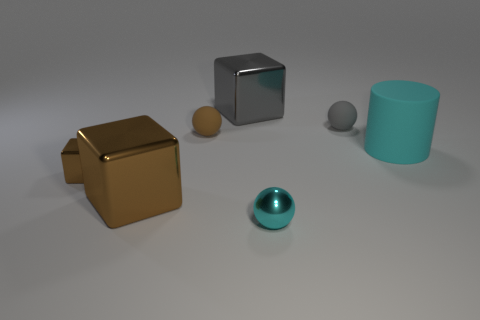There is a big gray thing that is the same shape as the big brown object; what is its material?
Offer a very short reply. Metal. Do the large rubber object and the tiny cyan object have the same shape?
Offer a very short reply. No. There is a large object that is the same material as the brown ball; what shape is it?
Your answer should be very brief. Cylinder. Do the cyan object in front of the cyan matte object and the metallic thing that is behind the large cyan rubber object have the same size?
Ensure brevity in your answer.  No. Is the number of big cylinders in front of the cyan metal sphere greater than the number of small brown metallic blocks to the left of the small block?
Provide a succinct answer. No. How many other objects are the same color as the tiny block?
Your answer should be compact. 2. There is a cylinder; is its color the same as the tiny thing that is to the right of the cyan ball?
Ensure brevity in your answer.  No. How many big metallic cubes are behind the tiny metallic thing on the right side of the small shiny block?
Make the answer very short. 2. Is there anything else that is made of the same material as the cyan cylinder?
Your response must be concise. Yes. There is a small brown thing in front of the tiny matte ball that is to the left of the object that is in front of the big brown metallic thing; what is its material?
Make the answer very short. Metal. 